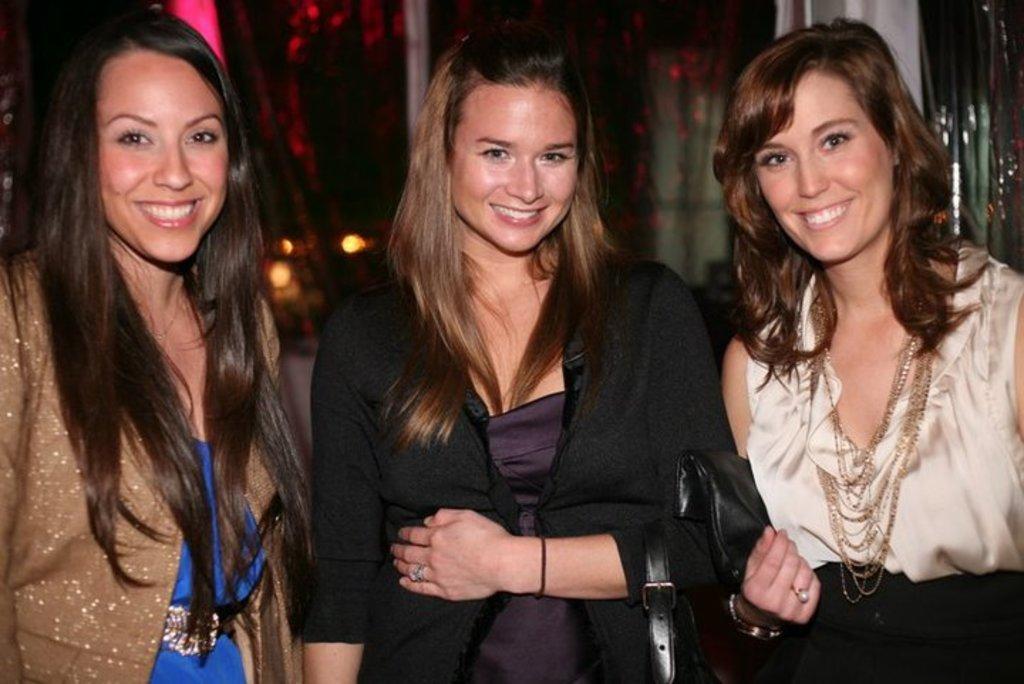In one or two sentences, can you explain what this image depicts? In this picture there are three persons standing and smiling. At the back there is a curtain. 